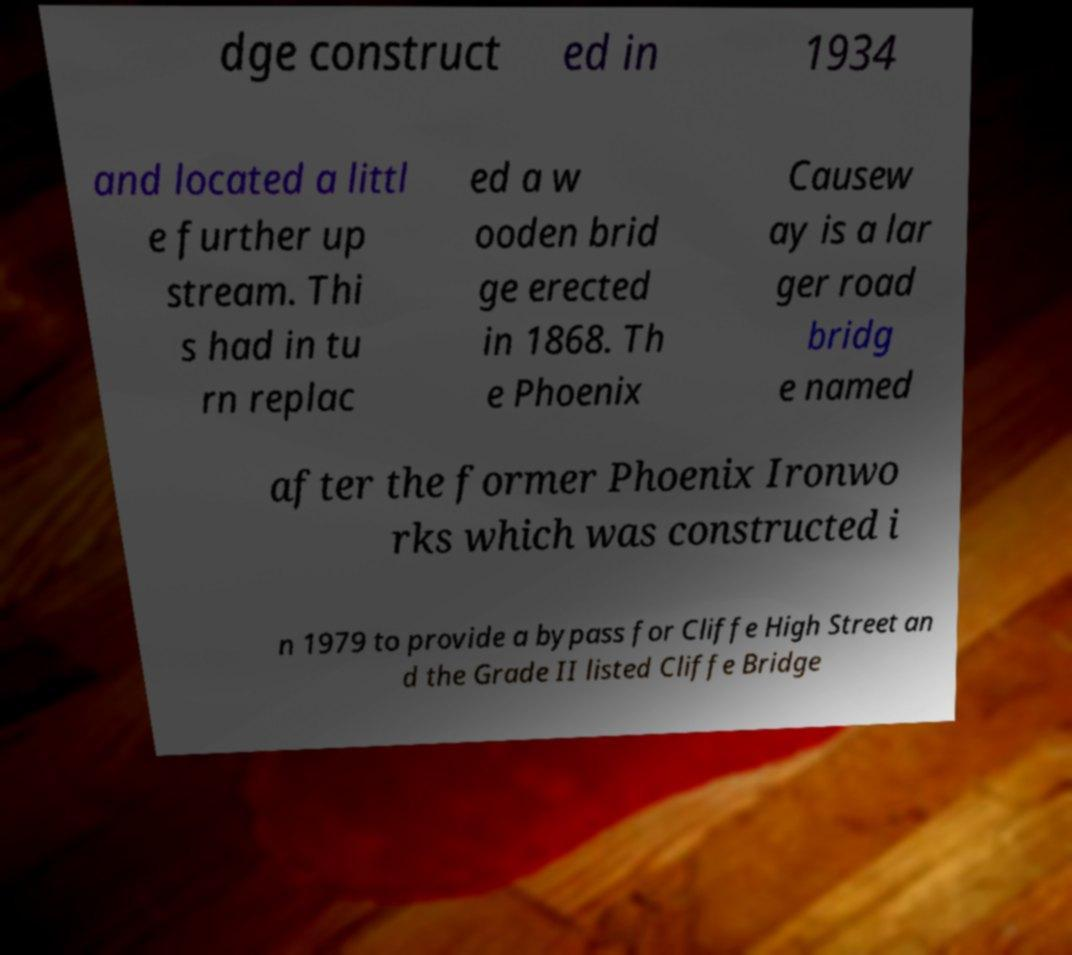For documentation purposes, I need the text within this image transcribed. Could you provide that? dge construct ed in 1934 and located a littl e further up stream. Thi s had in tu rn replac ed a w ooden brid ge erected in 1868. Th e Phoenix Causew ay is a lar ger road bridg e named after the former Phoenix Ironwo rks which was constructed i n 1979 to provide a bypass for Cliffe High Street an d the Grade II listed Cliffe Bridge 